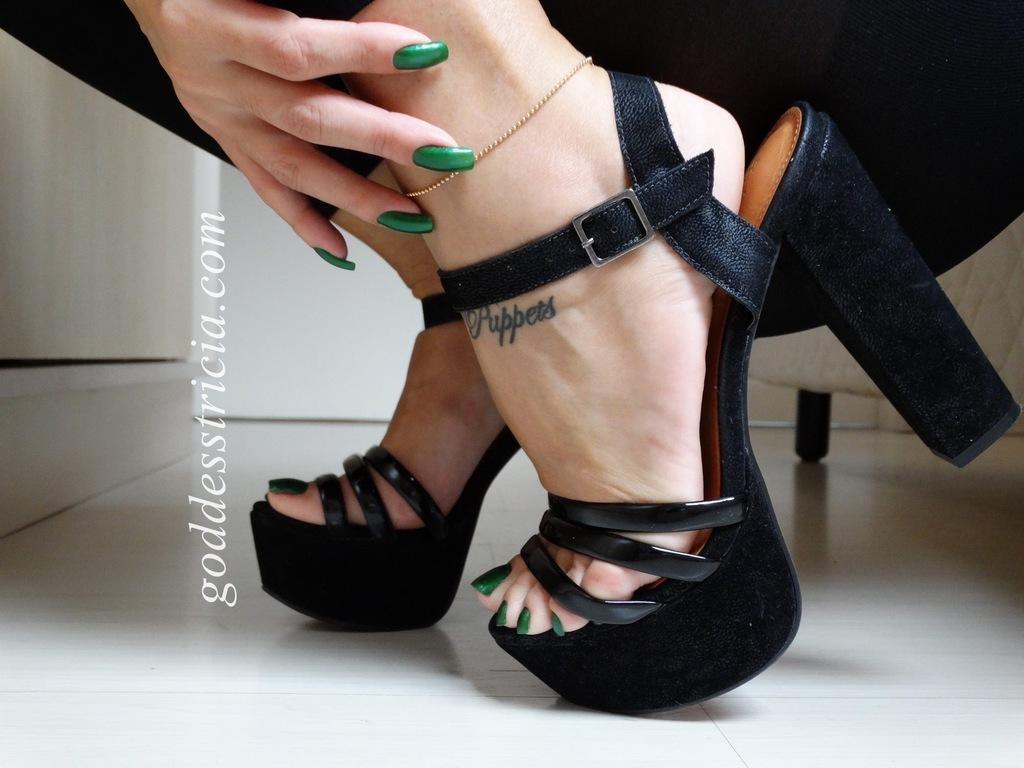What body part is visible in the image? There are legs of a person in the image. What other body part can be seen in the image? There is a hand in the image. What else is present in the image besides body parts? There is text in the image. What can be seen in the background of the image? There is a wall in the background of the image. What type of advice is the person in the image giving to the viewer? There is no indication in the image that the person is giving advice to the viewer. 